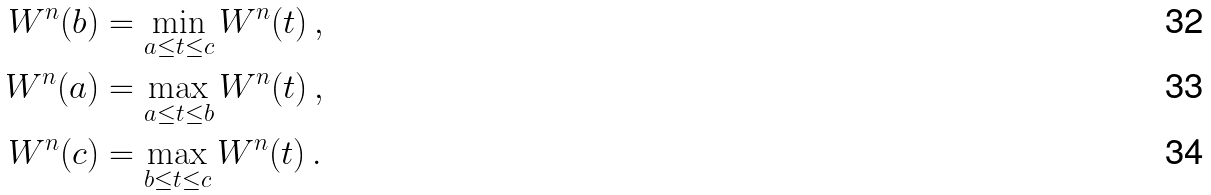<formula> <loc_0><loc_0><loc_500><loc_500>W ^ { n } ( b ) & = \min _ { a \leq t \leq c } W ^ { n } ( t ) \, , \\ W ^ { n } ( a ) & = \max _ { a \leq t \leq b } W ^ { n } ( t ) \, , \\ W ^ { n } ( c ) & = \max _ { b \leq t \leq c } W ^ { n } ( t ) \, .</formula> 